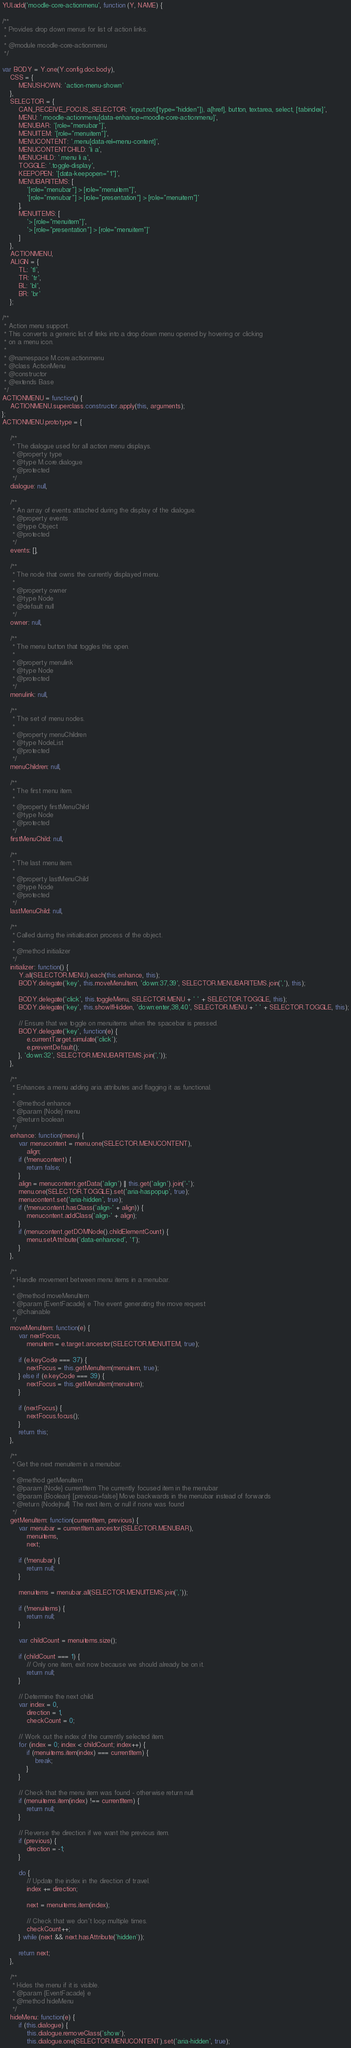Convert code to text. <code><loc_0><loc_0><loc_500><loc_500><_JavaScript_>YUI.add('moodle-core-actionmenu', function (Y, NAME) {

/**
 * Provides drop down menus for list of action links.
 *
 * @module moodle-core-actionmenu
 */

var BODY = Y.one(Y.config.doc.body),
    CSS = {
        MENUSHOWN: 'action-menu-shown'
    },
    SELECTOR = {
        CAN_RECEIVE_FOCUS_SELECTOR: 'input:not([type="hidden"]), a[href], button, textarea, select, [tabindex]',
        MENU: '.moodle-actionmenu[data-enhance=moodle-core-actionmenu]',
        MENUBAR: '[role="menubar"]',
        MENUITEM: '[role="menuitem"]',
        MENUCONTENT: '.menu[data-rel=menu-content]',
        MENUCONTENTCHILD: 'li a',
        MENUCHILD: '.menu li a',
        TOGGLE: '.toggle-display',
        KEEPOPEN: '[data-keepopen="1"]',
        MENUBARITEMS: [
            '[role="menubar"] > [role="menuitem"]',
            '[role="menubar"] > [role="presentation"] > [role="menuitem"]'
        ],
        MENUITEMS: [
            '> [role="menuitem"]',
            '> [role="presentation"] > [role="menuitem"]'
        ]
    },
    ACTIONMENU,
    ALIGN = {
        TL: 'tl',
        TR: 'tr',
        BL: 'bl',
        BR: 'br'
    };

/**
 * Action menu support.
 * This converts a generic list of links into a drop down menu opened by hovering or clicking
 * on a menu icon.
 *
 * @namespace M.core.actionmenu
 * @class ActionMenu
 * @constructor
 * @extends Base
 */
ACTIONMENU = function() {
    ACTIONMENU.superclass.constructor.apply(this, arguments);
};
ACTIONMENU.prototype = {

    /**
     * The dialogue used for all action menu displays.
     * @property type
     * @type M.core.dialogue
     * @protected
     */
    dialogue: null,

    /**
     * An array of events attached during the display of the dialogue.
     * @property events
     * @type Object
     * @protected
     */
    events: [],

    /**
     * The node that owns the currently displayed menu.
     *
     * @property owner
     * @type Node
     * @default null
     */
    owner: null,

    /**
     * The menu button that toggles this open.
     *
     * @property menulink
     * @type Node
     * @protected
     */
    menulink: null,

    /**
     * The set of menu nodes.
     *
     * @property menuChildren
     * @type NodeList
     * @protected
     */
    menuChildren: null,

    /**
     * The first menu item.
     *
     * @property firstMenuChild
     * @type Node
     * @protected
     */
    firstMenuChild: null,

    /**
     * The last menu item.
     *
     * @property lastMenuChild
     * @type Node
     * @protected
     */
    lastMenuChild: null,

    /**
     * Called during the initialisation process of the object.
     *
     * @method initializer
     */
    initializer: function() {
        Y.all(SELECTOR.MENU).each(this.enhance, this);
        BODY.delegate('key', this.moveMenuItem, 'down:37,39', SELECTOR.MENUBARITEMS.join(','), this);

        BODY.delegate('click', this.toggleMenu, SELECTOR.MENU + ' ' + SELECTOR.TOGGLE, this);
        BODY.delegate('key', this.showIfHidden, 'down:enter,38,40', SELECTOR.MENU + ' ' + SELECTOR.TOGGLE, this);

        // Ensure that we toggle on menuitems when the spacebar is pressed.
        BODY.delegate('key', function(e) {
            e.currentTarget.simulate('click');
            e.preventDefault();
        }, 'down:32', SELECTOR.MENUBARITEMS.join(','));
    },

    /**
     * Enhances a menu adding aria attributes and flagging it as functional.
     *
     * @method enhance
     * @param {Node} menu
     * @return boolean
     */
    enhance: function(menu) {
        var menucontent = menu.one(SELECTOR.MENUCONTENT),
            align;
        if (!menucontent) {
            return false;
        }
        align = menucontent.getData('align') || this.get('align').join('-');
        menu.one(SELECTOR.TOGGLE).set('aria-haspopup', true);
        menucontent.set('aria-hidden', true);
        if (!menucontent.hasClass('align-' + align)) {
            menucontent.addClass('align-' + align);
        }
        if (menucontent.getDOMNode().childElementCount) {
            menu.setAttribute('data-enhanced', '1');
        }
    },

    /**
     * Handle movement between menu items in a menubar.
     *
     * @method moveMenuItem
     * @param {EventFacade} e The event generating the move request
     * @chainable
     */
    moveMenuItem: function(e) {
        var nextFocus,
            menuitem = e.target.ancestor(SELECTOR.MENUITEM, true);

        if (e.keyCode === 37) {
            nextFocus = this.getMenuItem(menuitem, true);
        } else if (e.keyCode === 39) {
            nextFocus = this.getMenuItem(menuitem);
        }

        if (nextFocus) {
            nextFocus.focus();
        }
        return this;
    },

    /**
     * Get the next menuitem in a menubar.
     *
     * @method getMenuItem
     * @param {Node} currentItem The currently focused item in the menubar
     * @param {Boolean} [previous=false] Move backwards in the menubar instead of forwards
     * @return {Node|null} The next item, or null if none was found
     */
    getMenuItem: function(currentItem, previous) {
        var menubar = currentItem.ancestor(SELECTOR.MENUBAR),
            menuitems,
            next;

        if (!menubar) {
            return null;
        }

        menuitems = menubar.all(SELECTOR.MENUITEMS.join(','));

        if (!menuitems) {
            return null;
        }

        var childCount = menuitems.size();

        if (childCount === 1) {
            // Only one item, exit now because we should already be on it.
            return null;
        }

        // Determine the next child.
        var index = 0,
            direction = 1,
            checkCount = 0;

        // Work out the index of the currently selected item.
        for (index = 0; index < childCount; index++) {
            if (menuitems.item(index) === currentItem) {
                break;
            }
        }

        // Check that the menu item was found - otherwise return null.
        if (menuitems.item(index) !== currentItem) {
            return null;
        }

        // Reverse the direction if we want the previous item.
        if (previous) {
            direction = -1;
        }

        do {
            // Update the index in the direction of travel.
            index += direction;

            next = menuitems.item(index);

            // Check that we don't loop multiple times.
            checkCount++;
        } while (next && next.hasAttribute('hidden'));

        return next;
    },

    /**
     * Hides the menu if it is visible.
     * @param {EventFacade} e
     * @method hideMenu
     */
    hideMenu: function(e) {
        if (this.dialogue) {
            this.dialogue.removeClass('show');
            this.dialogue.one(SELECTOR.MENUCONTENT).set('aria-hidden', true);</code> 